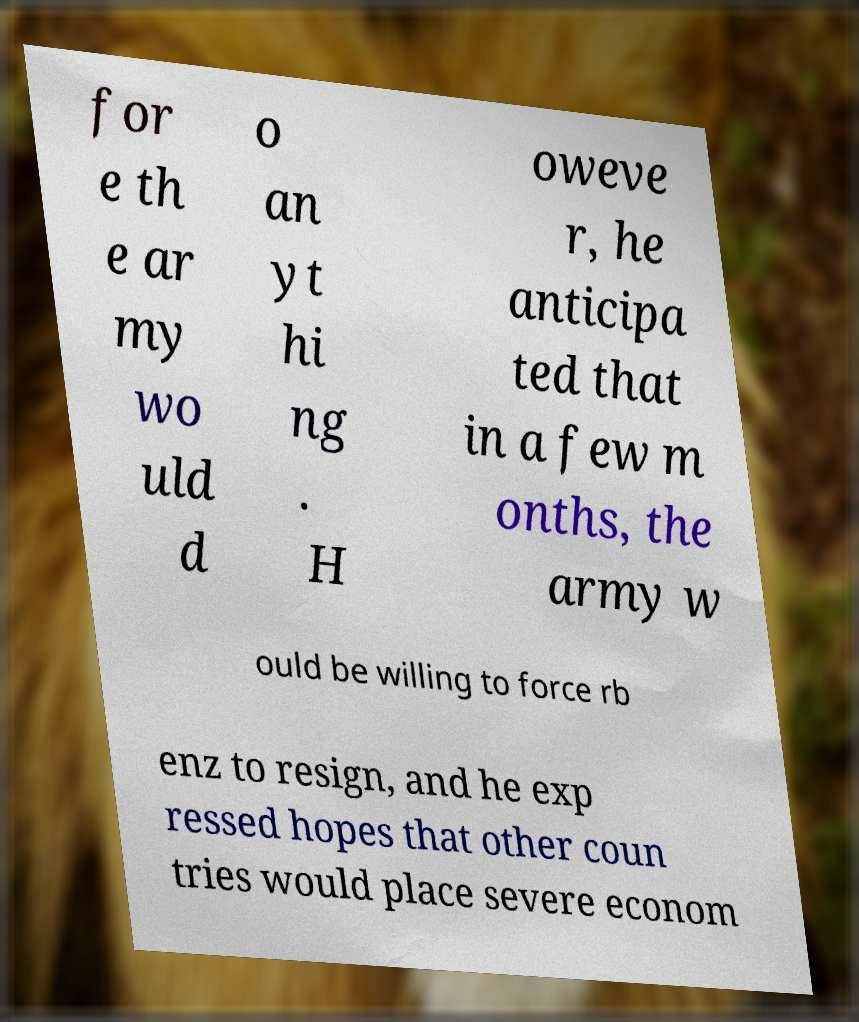There's text embedded in this image that I need extracted. Can you transcribe it verbatim? for e th e ar my wo uld d o an yt hi ng . H oweve r, he anticipa ted that in a few m onths, the army w ould be willing to force rb enz to resign, and he exp ressed hopes that other coun tries would place severe econom 